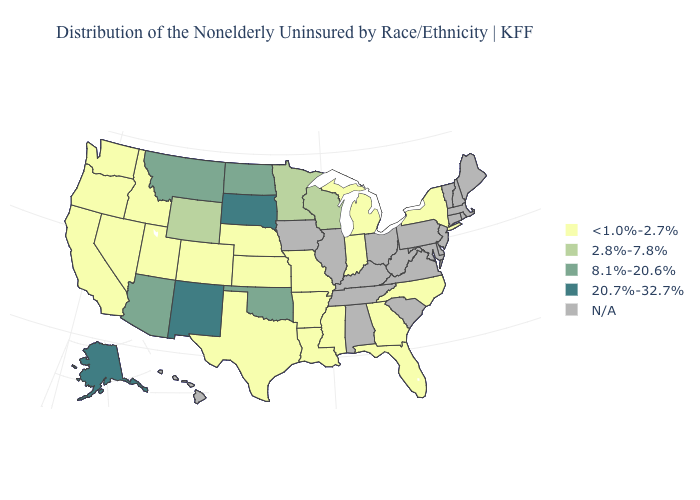Name the states that have a value in the range 2.8%-7.8%?
Quick response, please. Minnesota, Wisconsin, Wyoming. Name the states that have a value in the range 2.8%-7.8%?
Write a very short answer. Minnesota, Wisconsin, Wyoming. Among the states that border Oklahoma , does Missouri have the highest value?
Keep it brief. No. What is the value of North Carolina?
Be succinct. <1.0%-2.7%. Name the states that have a value in the range 2.8%-7.8%?
Keep it brief. Minnesota, Wisconsin, Wyoming. Name the states that have a value in the range 20.7%-32.7%?
Write a very short answer. Alaska, New Mexico, South Dakota. Among the states that border Mississippi , which have the highest value?
Keep it brief. Arkansas, Louisiana. Does Kansas have the highest value in the MidWest?
Concise answer only. No. Does the first symbol in the legend represent the smallest category?
Write a very short answer. Yes. What is the lowest value in states that border Minnesota?
Short answer required. 2.8%-7.8%. What is the value of New Hampshire?
Short answer required. N/A. Does Oklahoma have the lowest value in the South?
Be succinct. No. 